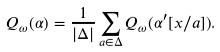<formula> <loc_0><loc_0><loc_500><loc_500>Q _ { \omega } ( \alpha ) = \frac { 1 } { | \Delta | } \sum _ { a \in \Delta } Q _ { \omega } ( \alpha ^ { \prime } [ x / a ] ) .</formula> 